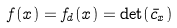Convert formula to latex. <formula><loc_0><loc_0><loc_500><loc_500>f ( x ) = f _ { d } ( x ) = \det ( \bar { c } _ { x } )</formula> 